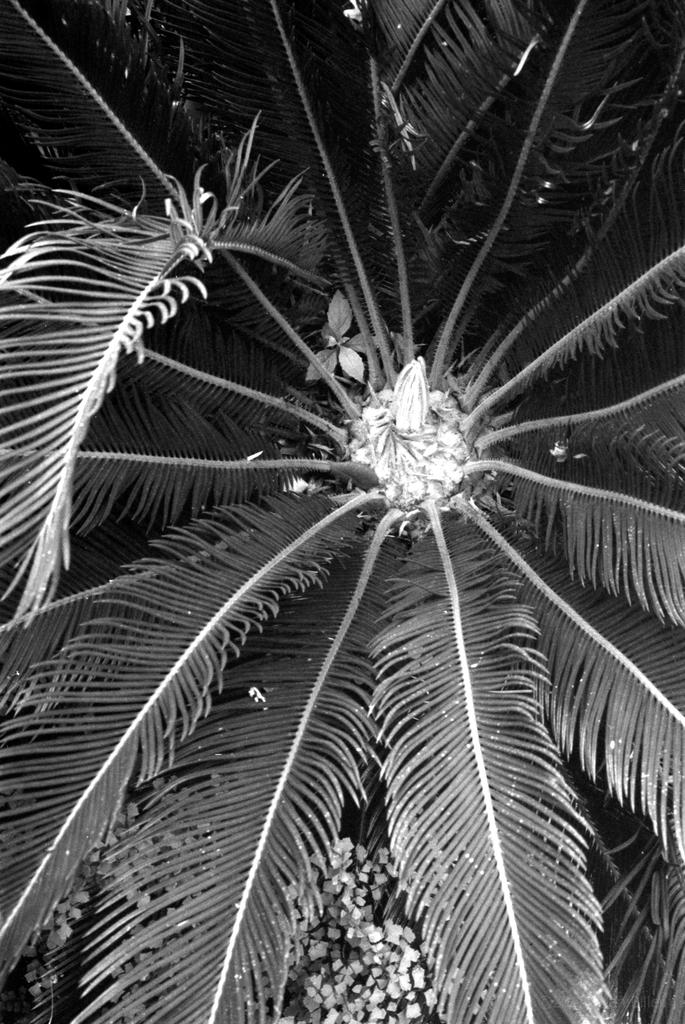What type of plant is depicted in the image? The image contains long leaves of a plant. What color scheme is used in the image? The image is black and white. What type of lipstick is visible on the plant in the image? There is no lipstick present in the image; it features long leaves of a plant in black and white. 